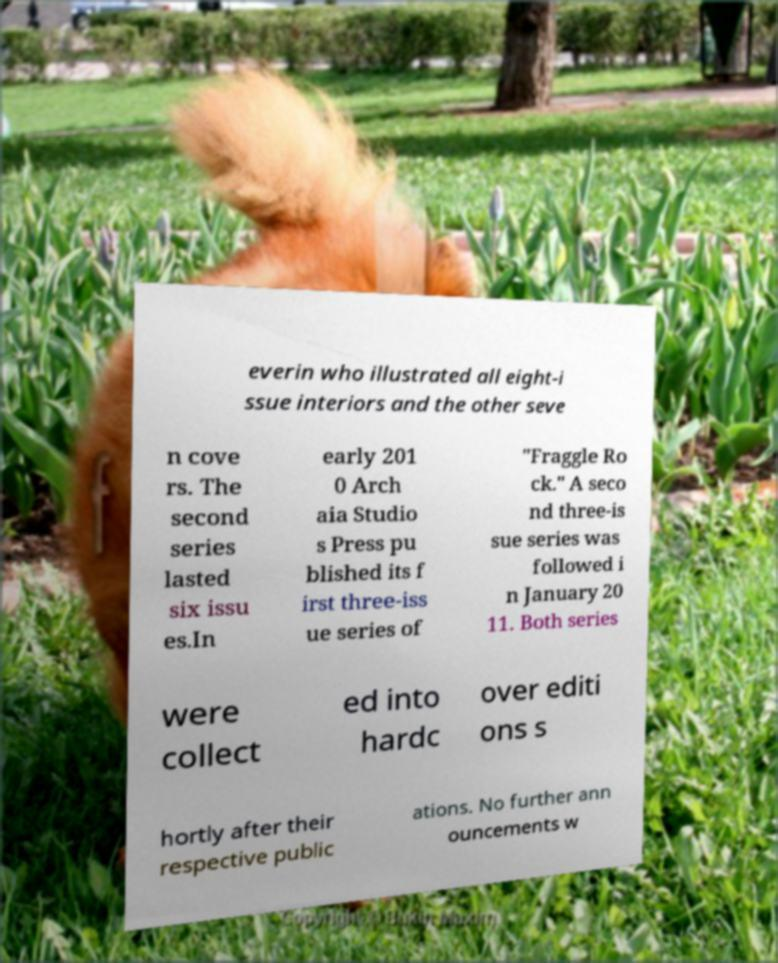I need the written content from this picture converted into text. Can you do that? everin who illustrated all eight-i ssue interiors and the other seve n cove rs. The second series lasted six issu es.In early 201 0 Arch aia Studio s Press pu blished its f irst three-iss ue series of "Fraggle Ro ck." A seco nd three-is sue series was followed i n January 20 11. Both series were collect ed into hardc over editi ons s hortly after their respective public ations. No further ann ouncements w 